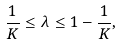Convert formula to latex. <formula><loc_0><loc_0><loc_500><loc_500>\frac { 1 } { K } \leq \lambda \leq 1 - \frac { 1 } { K } ,</formula> 